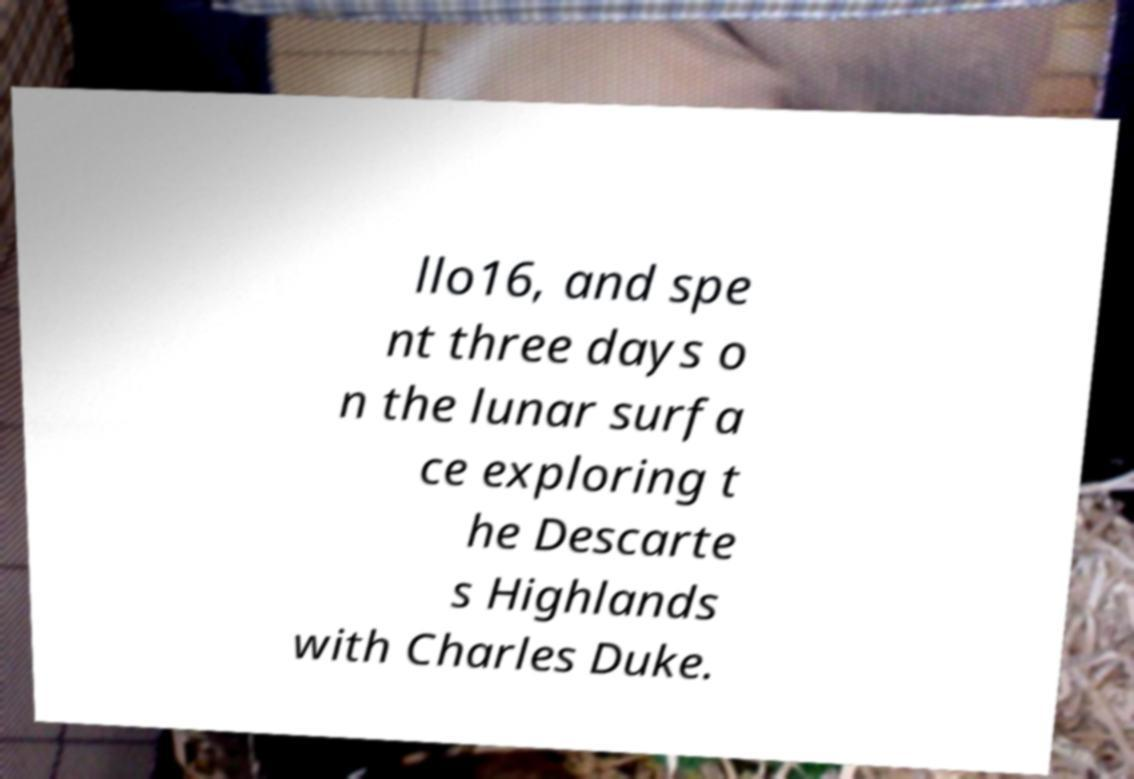Can you accurately transcribe the text from the provided image for me? llo16, and spe nt three days o n the lunar surfa ce exploring t he Descarte s Highlands with Charles Duke. 